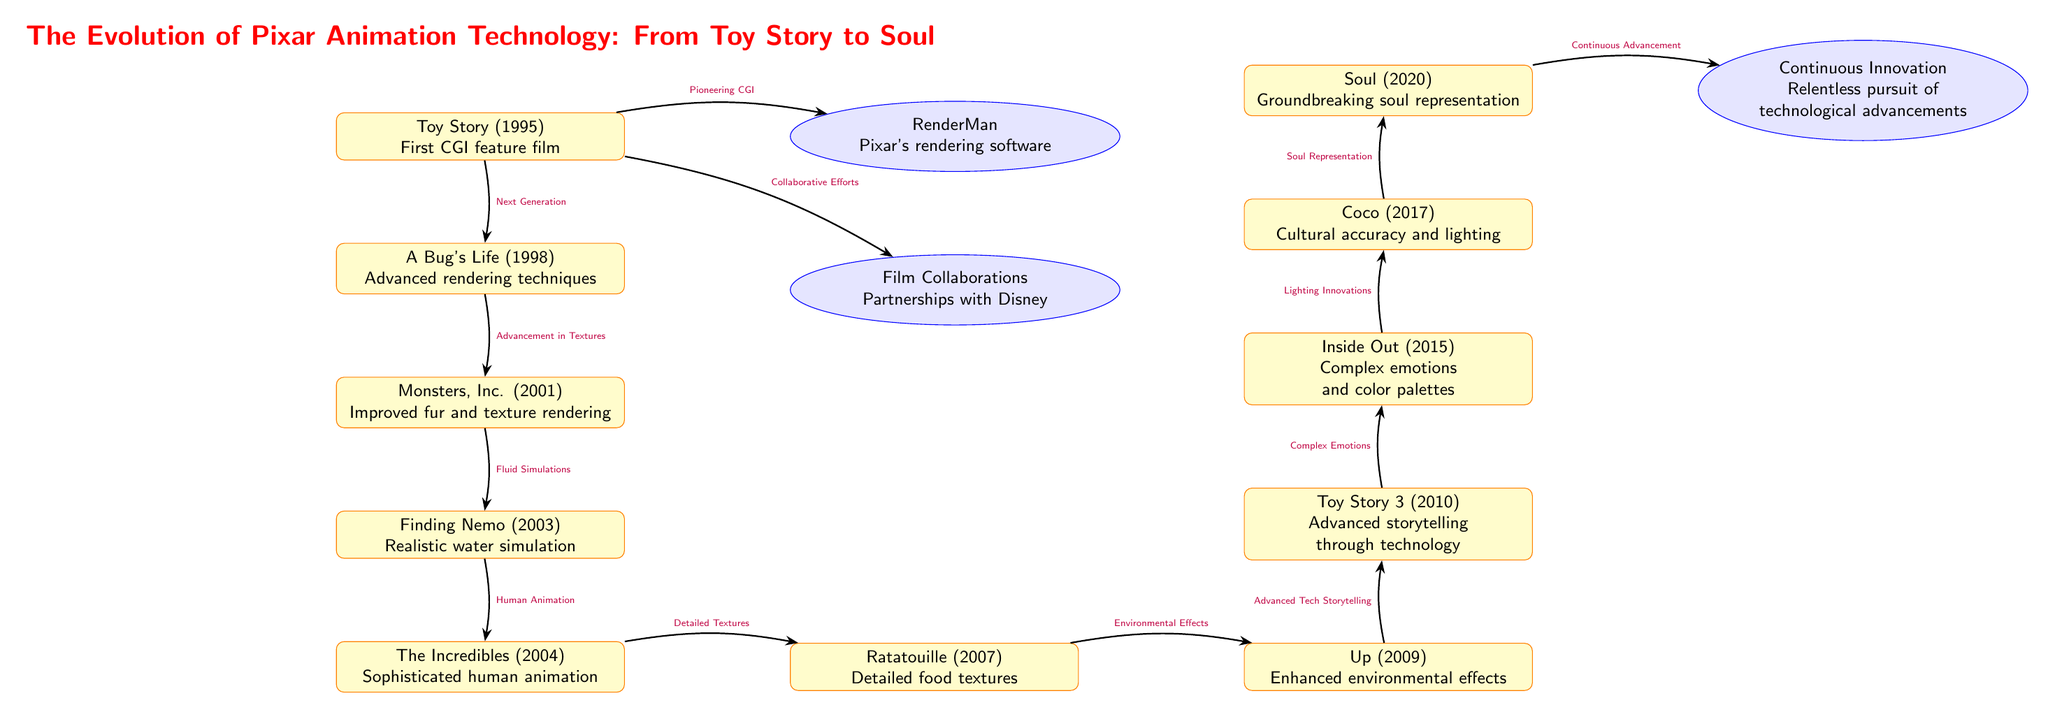What is the first movie listed in the diagram? The diagram starts with Toy Story (1995) which is positioned at the top as the first movie.
Answer: Toy Story (1995) How many movies are featured in the diagram? By counting all the movie nodes in the diagram, we find a total of 11 films from Toy Story to Soul.
Answer: 11 What technology is associated with Toy Story? The arrow pointed from Toy Story to RenderMan indicates that RenderMan is the associated technology developed for it.
Answer: RenderMan Which movie introduced realistic water simulation? The arrow from Monsters, Inc. points to Finding Nemo (2003), and the label specifies it introduced realistic water simulation.
Answer: Finding Nemo (2003) What was the main advancement from A Bug's Life to Monsters, Inc.? The diagram indicates the advancement is related to Textures, which is noted in the edge label between those two movies.
Answer: Advancement in Textures Which movie demonstrates ground-breaking soul representation? The diagram specifically indicates Soul (2020) is the movie that features groundbreaking soul representation.
Answer: Soul (2020) What type of relationships can be found between the movies and technologies? The diagram shows relationships labeled as advancements, innovations, and collaborations, connecting movies to various technologies they introduced or enhanced.
Answer: Advancements, Innovations, Collaborations What does the final node in the diagram represent? The final node labeled Continuous Innovation signifies the ongoing pursuit of technological advancements in animation, culminating from previous films and technologies.
Answer: Continuous Innovation Which year did Coco release? Referring to the diagram, Coco is depicted just above Soul and marked with the release year 2017.
Answer: 2017 What advancement does Up (2009) represent? The arrow from Ratatouille to Up clearly states it represents Environmental Effects based on its technological advancements.
Answer: Environmental Effects 